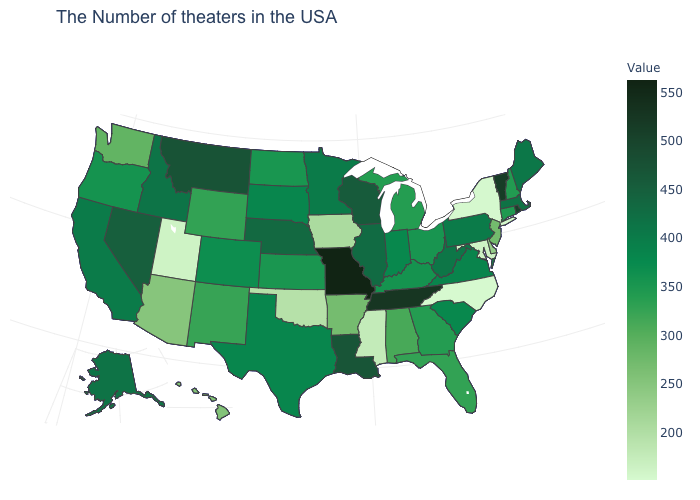Among the states that border Arizona , does Nevada have the highest value?
Be succinct. Yes. Which states have the lowest value in the USA?
Short answer required. North Carolina. Does Pennsylvania have the lowest value in the Northeast?
Write a very short answer. No. Does North Carolina have the lowest value in the USA?
Short answer required. Yes. 